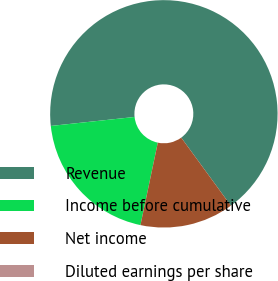Convert chart. <chart><loc_0><loc_0><loc_500><loc_500><pie_chart><fcel>Revenue<fcel>Income before cumulative<fcel>Net income<fcel>Diluted earnings per share<nl><fcel>66.67%<fcel>20.0%<fcel>13.33%<fcel>0.0%<nl></chart> 